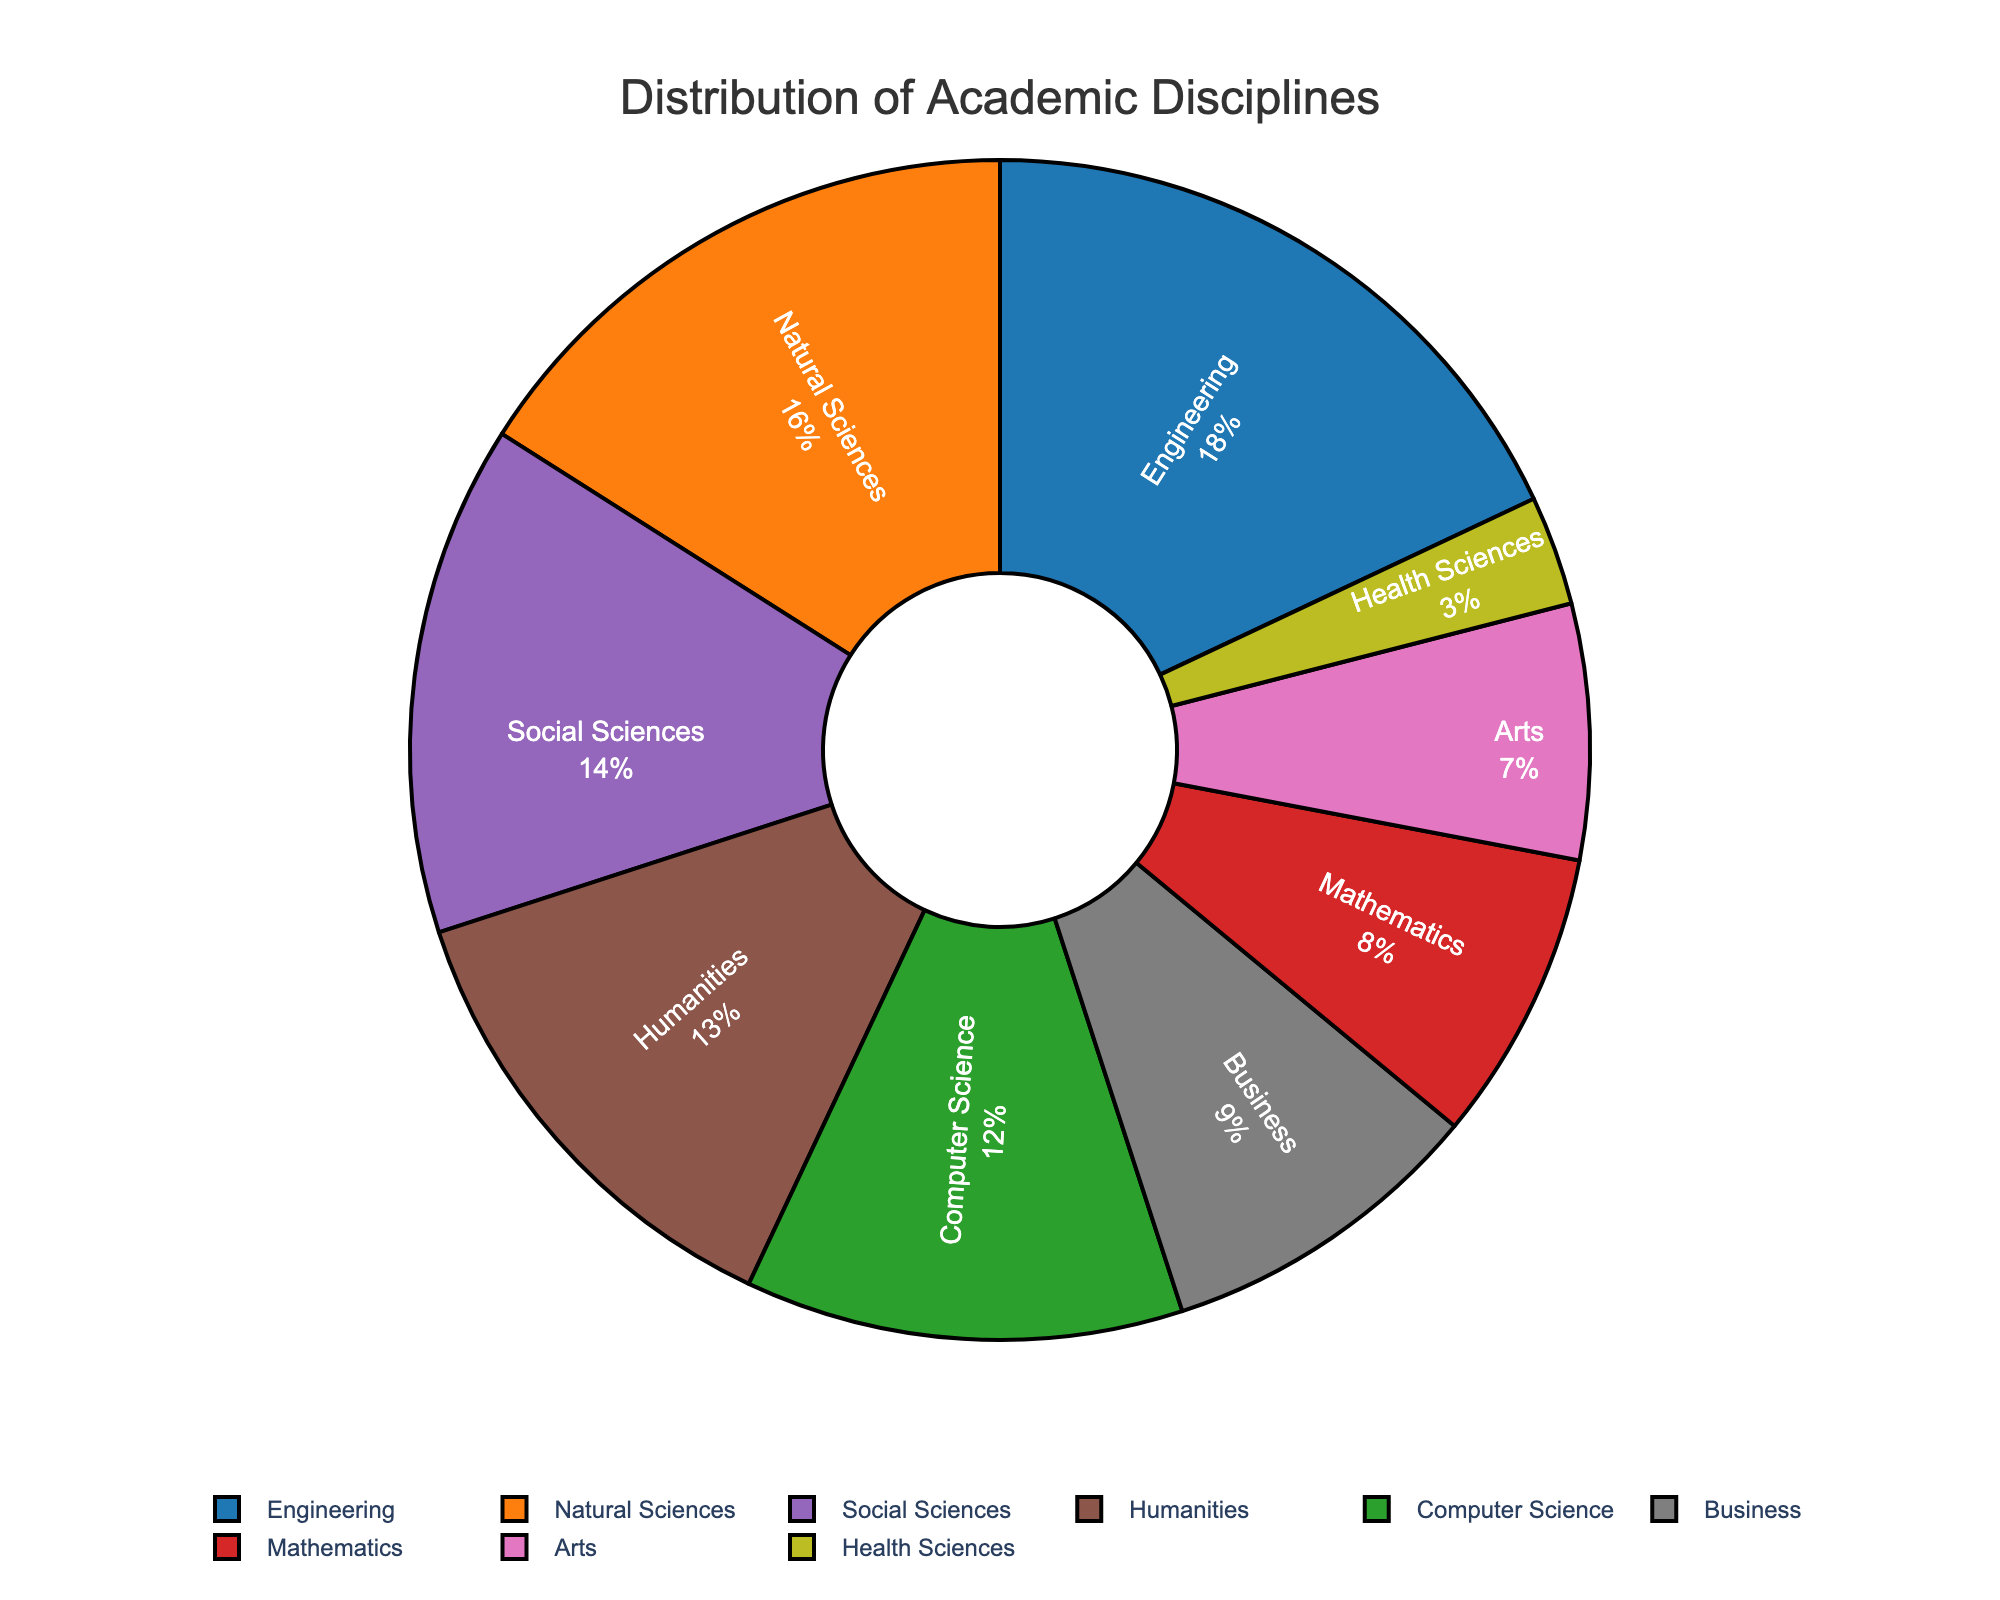What percentage of the disciplines belong to STEM fields (Engineering, Natural Sciences, Computer Science, Mathematics)? To find the percentage of STEM disciplines, sum the percentages of Engineering, Natural Sciences, Computer Science, and Mathematics (18% + 16% + 12% + 8% = 54%).
Answer: 54% What is the difference in percentage between Humanities and Arts? The Humanities have 13%, and the Arts have 7%, so the difference is 13% - 7% = 6%.
Answer: 6% How does the percentage of Business compare to that of Humanities? Which one is larger? Business has 9%, while Humanities have 13%. Since 13% is greater than 9%, Humanities is larger.
Answer: Humanities What is the combined percentage of Social Sciences and Health Sciences? Add the percentages of Social Sciences and Health Sciences (14% + 3% = 17%).
Answer: 17% Which discipline has the lowest percentage, and what is that percentage? The Health Sciences discipline has the lowest percentage at 3%.
Answer: Health Sciences, 3% List all disciplines that have a percentage below 10%. The disciplines with percentages below 10% are Mathematics (8%), Arts (7%), Business (9%), and Health Sciences (3%).
Answer: Mathematics, Arts, Business, Health Sciences How much larger is the proportion of Engineering compared to Arts? Engineering has 18%, and Arts have 7%. The difference is 18% - 7% = 11%.
Answer: 11% What is the average percentage of Computer Science, Social Sciences, and Arts combined? Combine the percentages of Computer Science, Social Sciences, and Arts (12% + 14% + 7% = 33%) and divide by 3 to get the average (33% / 3 = 11%).
Answer: 11% What percent of the total represents non-STEM fields (Social Sciences, Humanities, Arts, Business, Health Sciences)? Sum the percentages of Social Sciences, Humanities, Arts, Business, and Health Sciences (14% + 13% + 7% + 9% + 3% = 46%).
Answer: 46% Compare the percentage of Natural Sciences with the percentage of Social Sciences. Which one is higher? Natural Sciences have 16%, and Social Sciences have 14%. Natural Sciences are higher.
Answer: Natural Sciences 